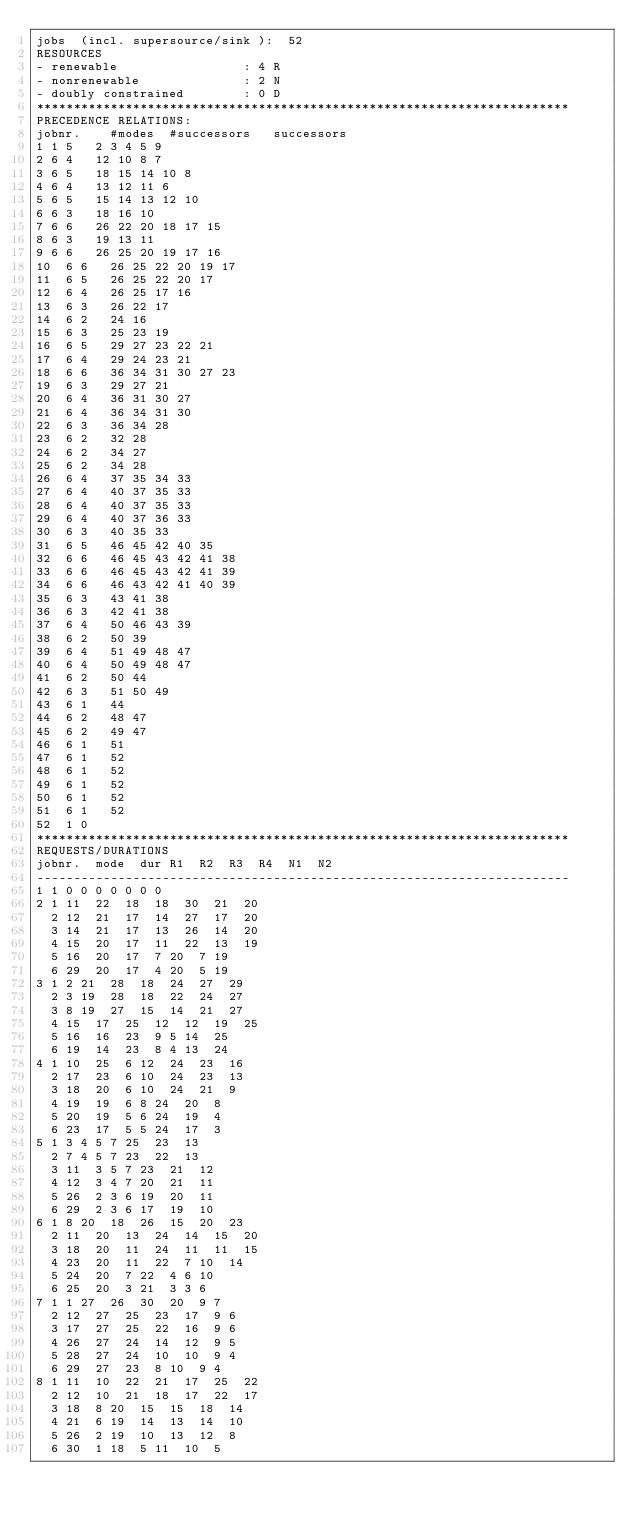Convert code to text. <code><loc_0><loc_0><loc_500><loc_500><_ObjectiveC_>jobs  (incl. supersource/sink ):	52
RESOURCES
- renewable                 : 4 R
- nonrenewable              : 2 N
- doubly constrained        : 0 D
************************************************************************
PRECEDENCE RELATIONS:
jobnr.    #modes  #successors   successors
1	1	5		2 3 4 5 9 
2	6	4		12 10 8 7 
3	6	5		18 15 14 10 8 
4	6	4		13 12 11 6 
5	6	5		15 14 13 12 10 
6	6	3		18 16 10 
7	6	6		26 22 20 18 17 15 
8	6	3		19 13 11 
9	6	6		26 25 20 19 17 16 
10	6	6		26 25 22 20 19 17 
11	6	5		26 25 22 20 17 
12	6	4		26 25 17 16 
13	6	3		26 22 17 
14	6	2		24 16 
15	6	3		25 23 19 
16	6	5		29 27 23 22 21 
17	6	4		29 24 23 21 
18	6	6		36 34 31 30 27 23 
19	6	3		29 27 21 
20	6	4		36 31 30 27 
21	6	4		36 34 31 30 
22	6	3		36 34 28 
23	6	2		32 28 
24	6	2		34 27 
25	6	2		34 28 
26	6	4		37 35 34 33 
27	6	4		40 37 35 33 
28	6	4		40 37 35 33 
29	6	4		40 37 36 33 
30	6	3		40 35 33 
31	6	5		46 45 42 40 35 
32	6	6		46 45 43 42 41 38 
33	6	6		46 45 43 42 41 39 
34	6	6		46 43 42 41 40 39 
35	6	3		43 41 38 
36	6	3		42 41 38 
37	6	4		50 46 43 39 
38	6	2		50 39 
39	6	4		51 49 48 47 
40	6	4		50 49 48 47 
41	6	2		50 44 
42	6	3		51 50 49 
43	6	1		44 
44	6	2		48 47 
45	6	2		49 47 
46	6	1		51 
47	6	1		52 
48	6	1		52 
49	6	1		52 
50	6	1		52 
51	6	1		52 
52	1	0		
************************************************************************
REQUESTS/DURATIONS
jobnr.	mode	dur	R1	R2	R3	R4	N1	N2	
------------------------------------------------------------------------
1	1	0	0	0	0	0	0	0	
2	1	11	22	18	18	30	21	20	
	2	12	21	17	14	27	17	20	
	3	14	21	17	13	26	14	20	
	4	15	20	17	11	22	13	19	
	5	16	20	17	7	20	7	19	
	6	29	20	17	4	20	5	19	
3	1	2	21	28	18	24	27	29	
	2	3	19	28	18	22	24	27	
	3	8	19	27	15	14	21	27	
	4	15	17	25	12	12	19	25	
	5	16	16	23	9	5	14	25	
	6	19	14	23	8	4	13	24	
4	1	10	25	6	12	24	23	16	
	2	17	23	6	10	24	23	13	
	3	18	20	6	10	24	21	9	
	4	19	19	6	8	24	20	8	
	5	20	19	5	6	24	19	4	
	6	23	17	5	5	24	17	3	
5	1	3	4	5	7	25	23	13	
	2	7	4	5	7	23	22	13	
	3	11	3	5	7	23	21	12	
	4	12	3	4	7	20	21	11	
	5	26	2	3	6	19	20	11	
	6	29	2	3	6	17	19	10	
6	1	8	20	18	26	15	20	23	
	2	11	20	13	24	14	15	20	
	3	18	20	11	24	11	11	15	
	4	23	20	11	22	7	10	14	
	5	24	20	7	22	4	6	10	
	6	25	20	3	21	3	3	6	
7	1	1	27	26	30	20	9	7	
	2	12	27	25	23	17	9	6	
	3	17	27	25	22	16	9	6	
	4	26	27	24	14	12	9	5	
	5	28	27	24	10	10	9	4	
	6	29	27	23	8	10	9	4	
8	1	11	10	22	21	17	25	22	
	2	12	10	21	18	17	22	17	
	3	18	8	20	15	15	18	14	
	4	21	6	19	14	13	14	10	
	5	26	2	19	10	13	12	8	
	6	30	1	18	5	11	10	5	</code> 